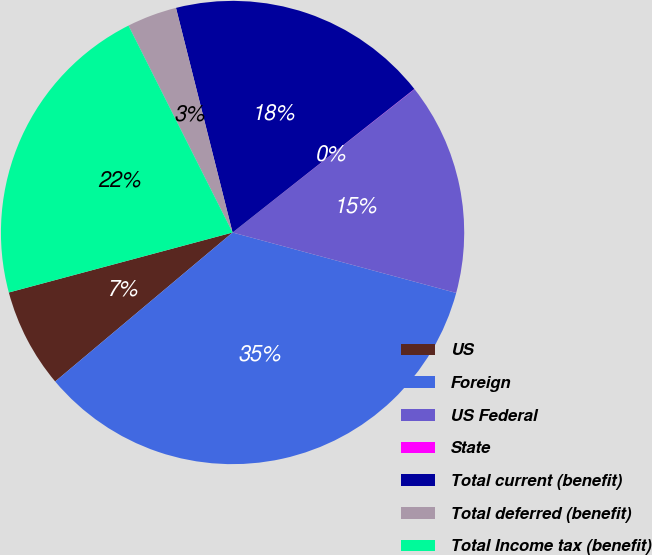Convert chart. <chart><loc_0><loc_0><loc_500><loc_500><pie_chart><fcel>US<fcel>Foreign<fcel>US Federal<fcel>State<fcel>Total current (benefit)<fcel>Total deferred (benefit)<fcel>Total Income tax (benefit)<nl><fcel>6.95%<fcel>34.68%<fcel>14.82%<fcel>0.02%<fcel>18.29%<fcel>3.49%<fcel>21.75%<nl></chart> 